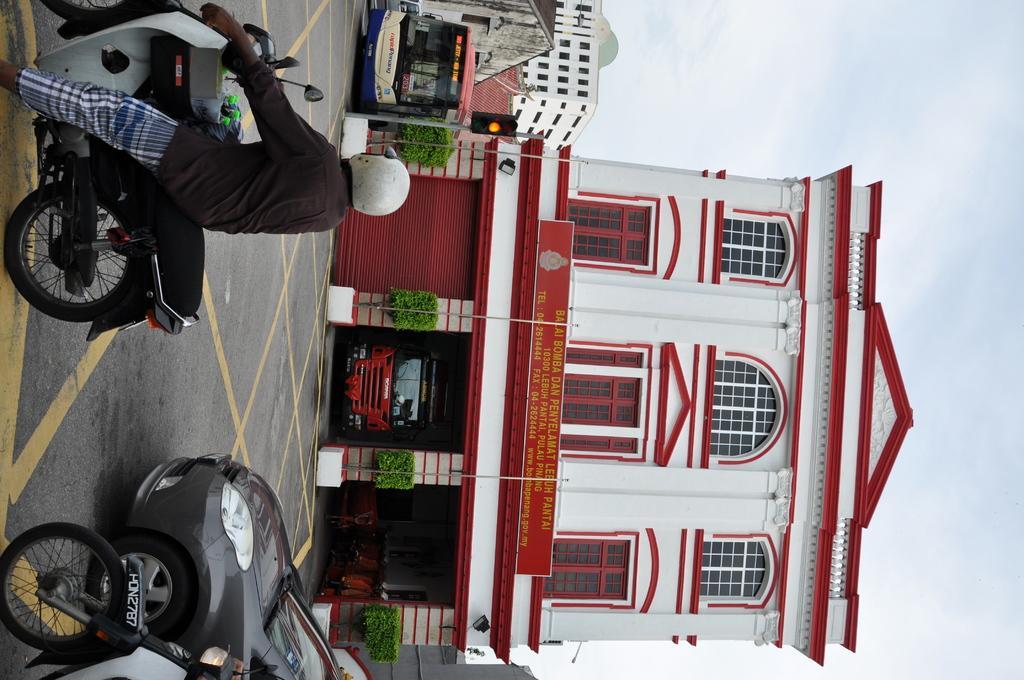Describe this image in one or two sentences. In this image we can see few buildings. There are few vehicles in the image. There is some text on the bus at the top of the image. A person is sitting on the motorbike. There are few plants in the image. We can see the sky at the right side of the image. 